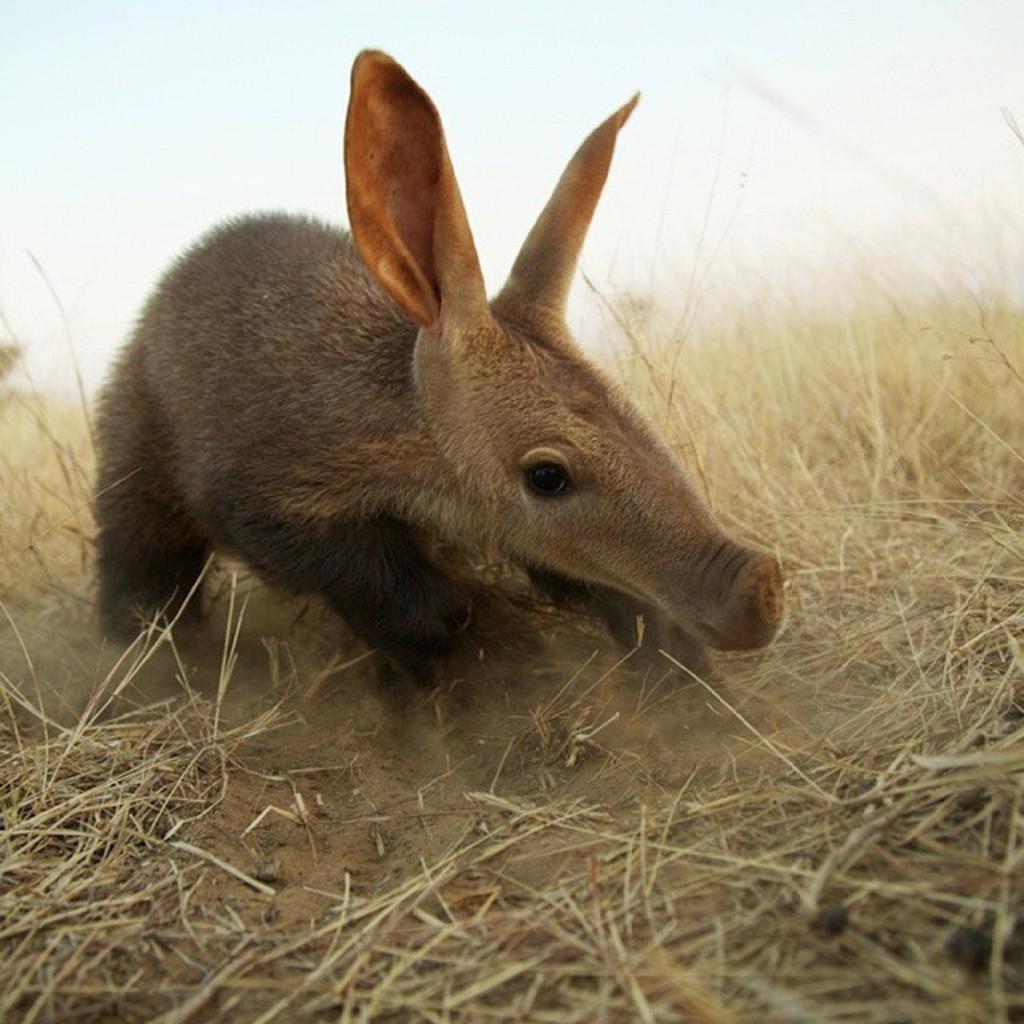In one or two sentences, can you explain what this image depicts? In this image there is an animal on a grassland, in the background it is blurred. 